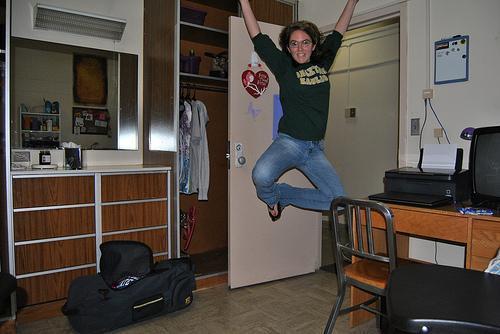How many persons are in the room?
Give a very brief answer. 1. 